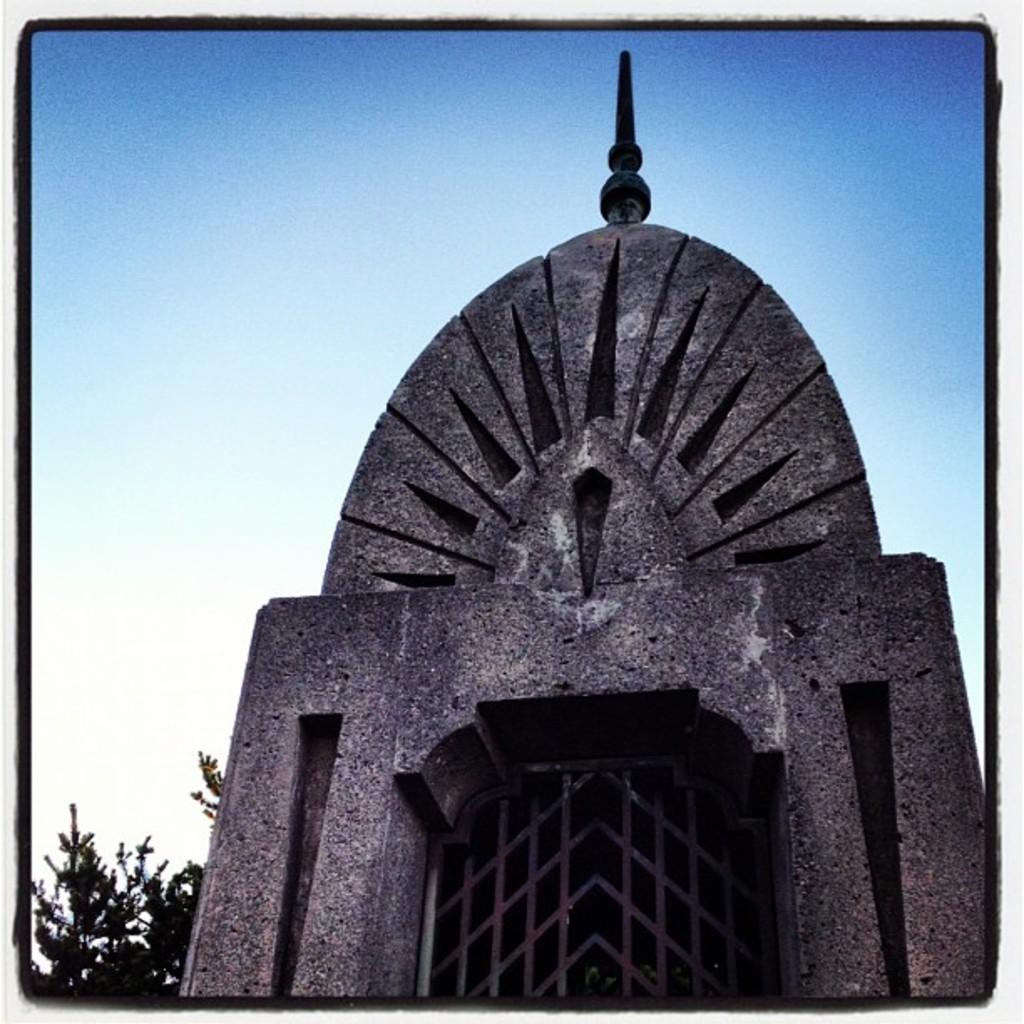What type of natural element is present in the image? There is a tree in the image. Can you tell if any digital manipulation has been applied to the image? Yes, the image appears to have been edited. What type of man-made structure can be seen in the image? There is a building in the image. What is visible at the top of the image? The sky is visible at the top of the image. Where is the stick located in the image? There is no stick present in the image. What type of waste can be seen in the image? There is no waste present in the image. 